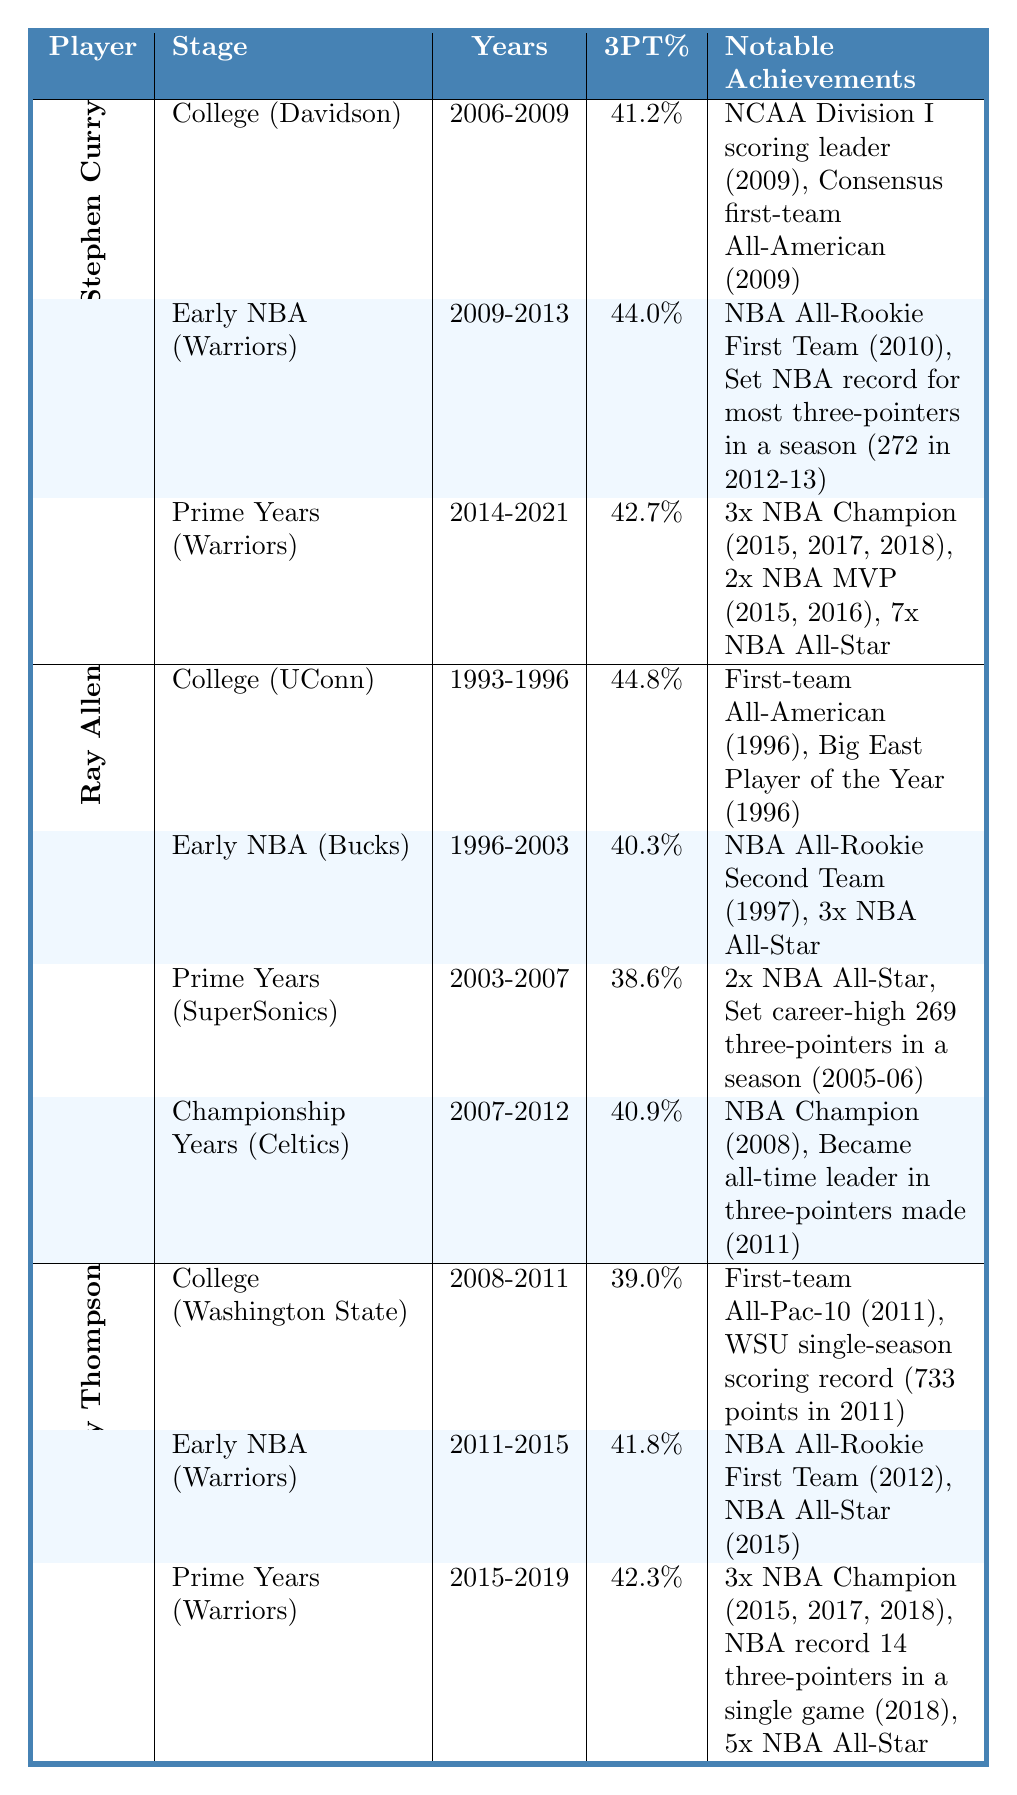What is Stephen Curry's highest three-point percentage in his career progression? In the table, Stephen Curry's highest three-point percentage is found in the "Early NBA Career" stage, which is 44.0%.
Answer: 44.0% Which player had the longest college career? In the table, both Stephen Curry and Ray Allen attended college for four years (2006-2009 for Curry and 1993-1996 for Allen), while Klay Thompson's college years span three years (2008-2011). Therefore, Ray Allen had the longer college career.
Answer: Ray Allen What is the average three-point percentage for Klay Thompson across all stages? Klay Thompson's three-point percentages are 39.0%, 41.8%, and 42.3%. To find the average: (39.0 + 41.8 + 42.3) / 3 = 41.0%.
Answer: 41.0% Did Ray Allen receive an NBA All-Star honor during his Prime Years? In the table, Ray Allen received 2x NBA All-Star honors during his Prime Years stage from 2003-2007, confirming he did achieve this recognition.
Answer: Yes What is the difference in three-point percentages between Ray Allen in College and Stephen Curry in Early NBA Career? For Ray Allen, the three-point percentage in college is 44.8%, while for Stephen Curry it is 44.0%. The difference is 44.8% - 44.0% = 0.8%.
Answer: 0.8% Which player had a notable achievement of being a three-time champion? The table shows that both Stephen Curry and Klay Thompson won 3 NBA Championships during their prime years with the Warriors (2015, 2017, 2018).
Answer: Stephen Curry and Klay Thompson What was the most recent stage in Ray Allen's career when he became the all-time leader in three-pointers made? According to the table, Ray Allen became the all-time leader in three-pointers made during his Championship Years stage (2007-2012) with the Boston Celtics.
Answer: Championship Years Who had a higher three-point percentage in their Prime Years, Curry or Thompson? In the table, Stephen Curry's three-point percentage during his Prime Years (2014-2021) is 42.7%, while Klay Thompson's percentage during his Prime Years (2015-2019) is 42.3%. Thus, Curry had a higher percentage.
Answer: Stephen Curry What are the total notable achievements listed for Stephen Curry? According to the table, Stephen Curry has five notable achievements listed under his career progression: two from Early NBA and three from Prime Years.
Answer: 5 